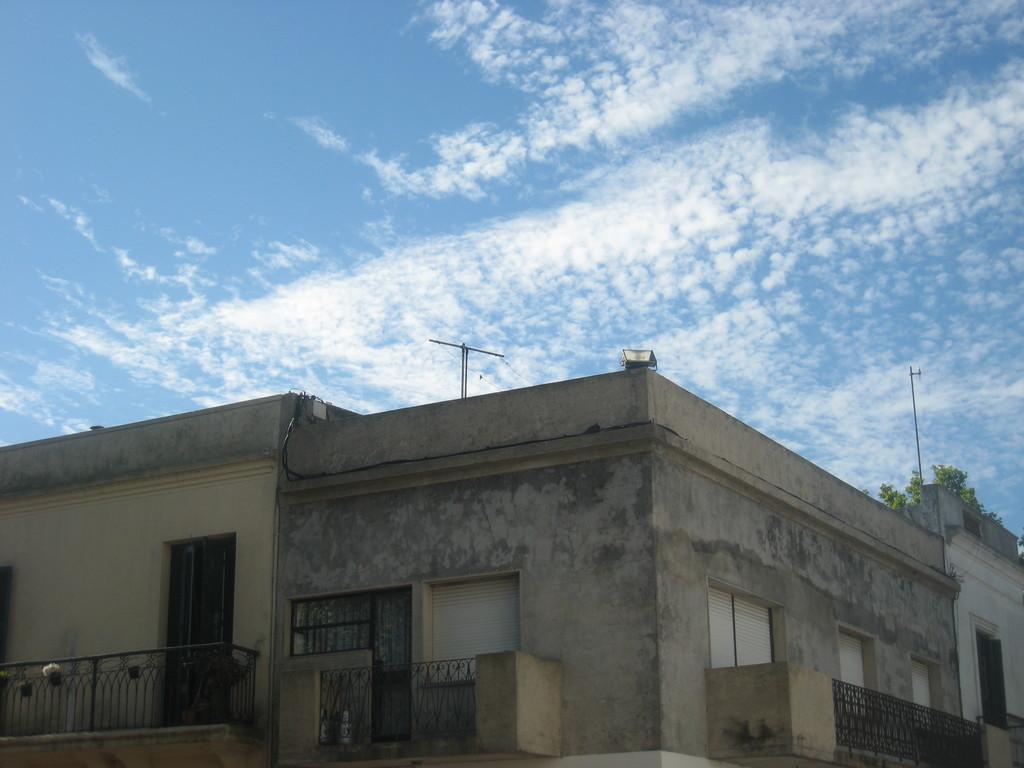What type of structure is present in the image? There is a building in the image. What features can be observed on the building? The building has windows and fences. What other objects are present in the image? There is a tree, a pole, and an antenna at the top of the building. What can be seen in the sky in the image? The sky is visible in the image. How long does it take for the smoke to dissipate from the image? There is no smoke present in the image, so it cannot be determined how long it would take to dissipate. 